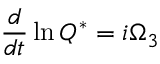Convert formula to latex. <formula><loc_0><loc_0><loc_500><loc_500>\frac { d } { d t } \ln Q ^ { * } = i \Omega _ { 3 }</formula> 